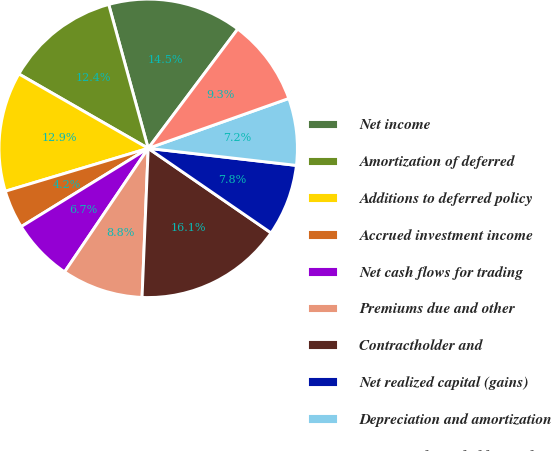Convert chart. <chart><loc_0><loc_0><loc_500><loc_500><pie_chart><fcel>Net income<fcel>Amortization of deferred<fcel>Additions to deferred policy<fcel>Accrued investment income<fcel>Net cash flows for trading<fcel>Premiums due and other<fcel>Contractholder and<fcel>Net realized capital (gains)<fcel>Depreciation and amortization<fcel>Mortgage loans held for sale<nl><fcel>14.51%<fcel>12.43%<fcel>12.95%<fcel>4.15%<fcel>6.74%<fcel>8.81%<fcel>16.06%<fcel>7.77%<fcel>7.25%<fcel>9.33%<nl></chart> 